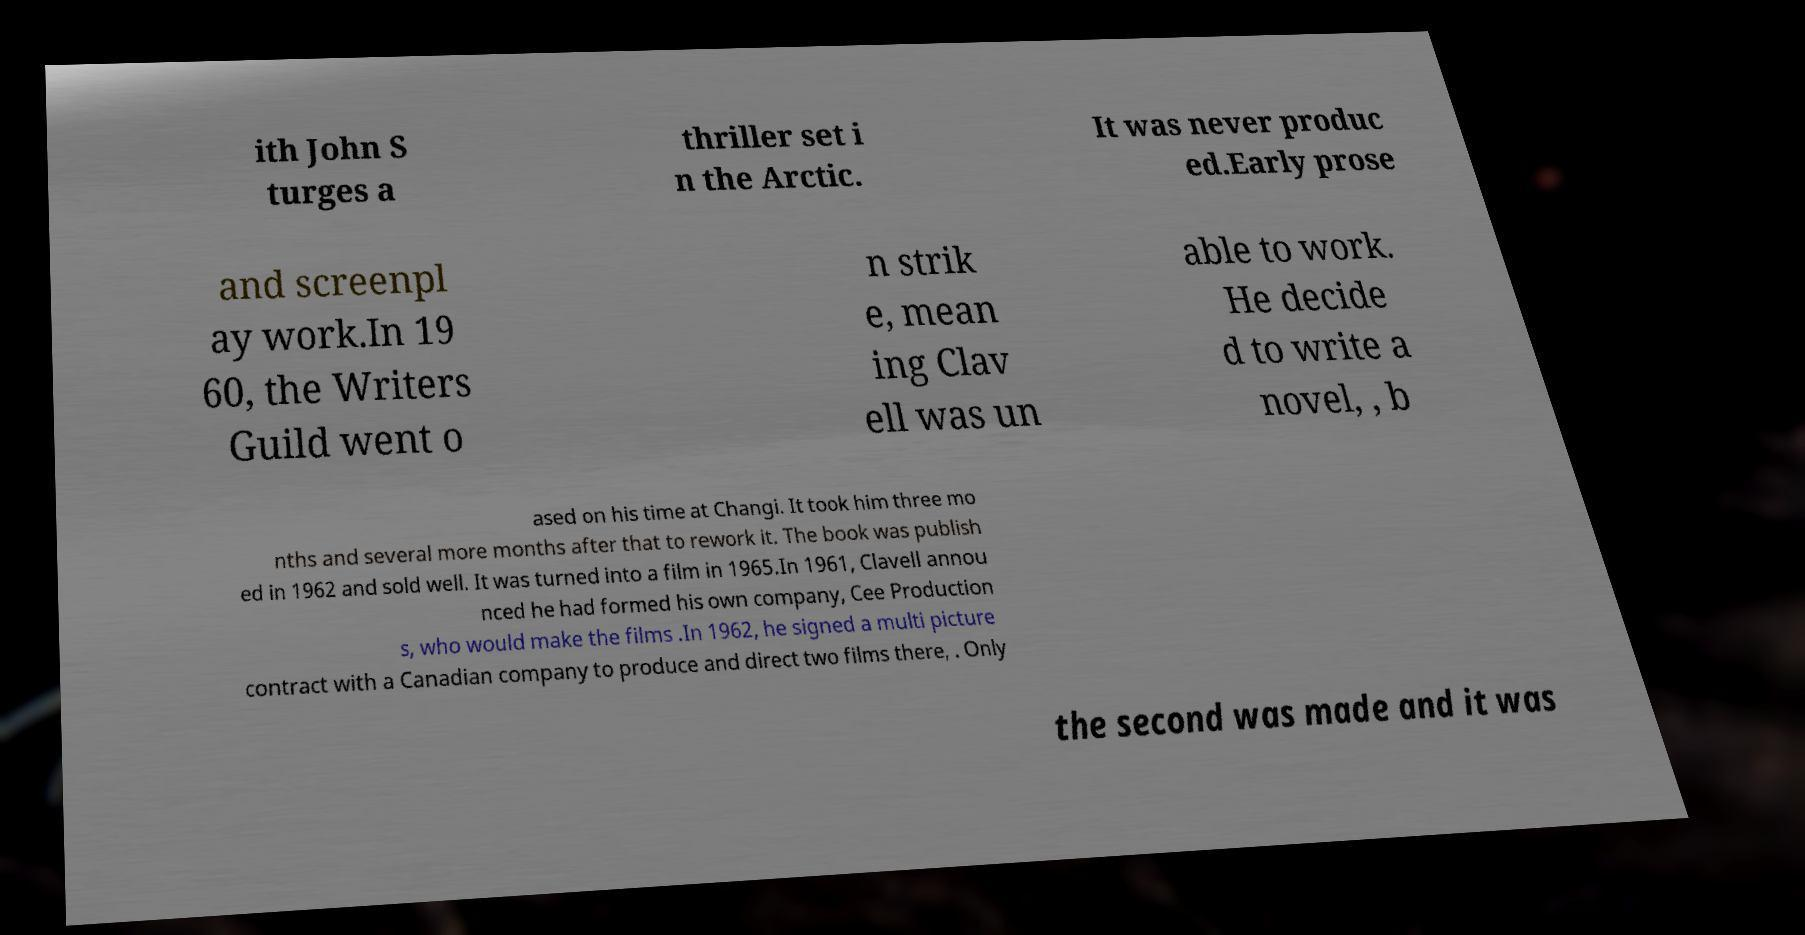What messages or text are displayed in this image? I need them in a readable, typed format. ith John S turges a thriller set i n the Arctic. It was never produc ed.Early prose and screenpl ay work.In 19 60, the Writers Guild went o n strik e, mean ing Clav ell was un able to work. He decide d to write a novel, , b ased on his time at Changi. It took him three mo nths and several more months after that to rework it. The book was publish ed in 1962 and sold well. It was turned into a film in 1965.In 1961, Clavell annou nced he had formed his own company, Cee Production s, who would make the films .In 1962, he signed a multi picture contract with a Canadian company to produce and direct two films there, . Only the second was made and it was 